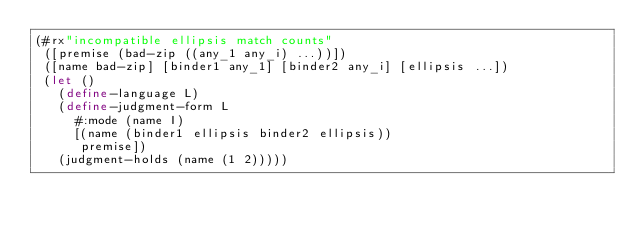<code> <loc_0><loc_0><loc_500><loc_500><_Racket_>(#rx"incompatible ellipsis match counts"
 ([premise (bad-zip ((any_1 any_i) ...))])
 ([name bad-zip] [binder1 any_1] [binder2 any_i] [ellipsis ...])
 (let ()
   (define-language L)
   (define-judgment-form L
     #:mode (name I)
     [(name (binder1 ellipsis binder2 ellipsis))
      premise])
   (judgment-holds (name (1 2)))))
</code> 